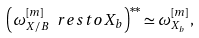Convert formula to latex. <formula><loc_0><loc_0><loc_500><loc_500>\left ( \omega _ { X / B } ^ { [ m ] } \ r e s t o { X _ { b } } \right ) ^ { * * } \simeq \omega _ { X _ { b } } ^ { [ m ] } ,</formula> 